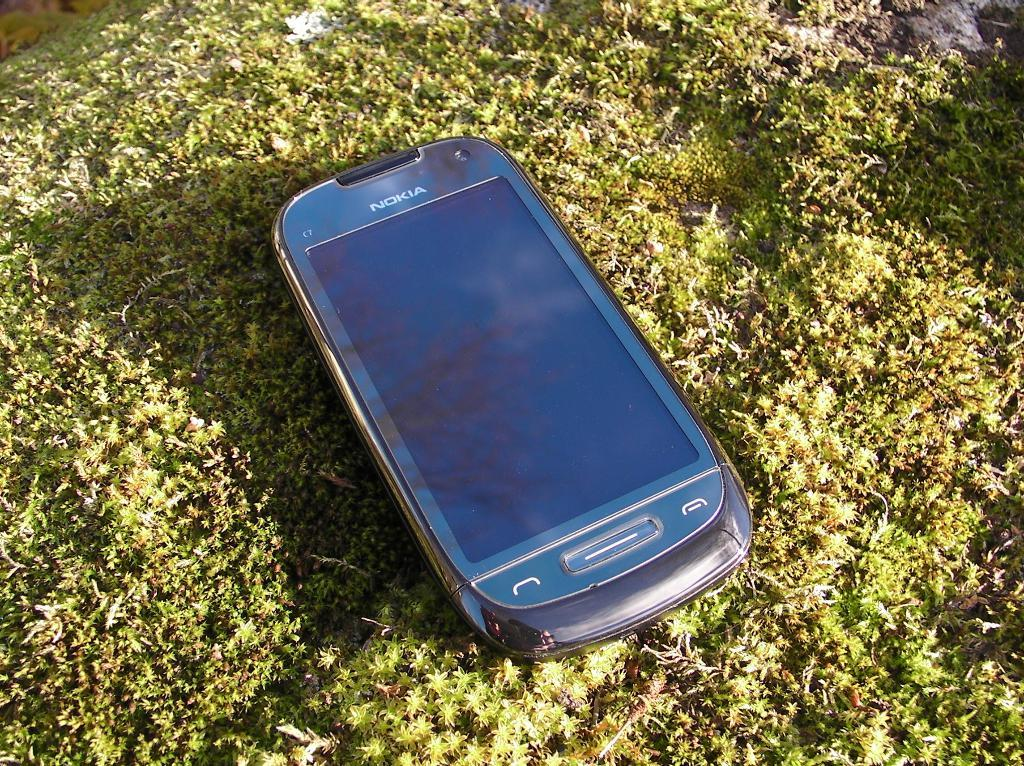<image>
Relay a brief, clear account of the picture shown. an unpowered Nokia branded cell phone sitting on a patch of grass. 